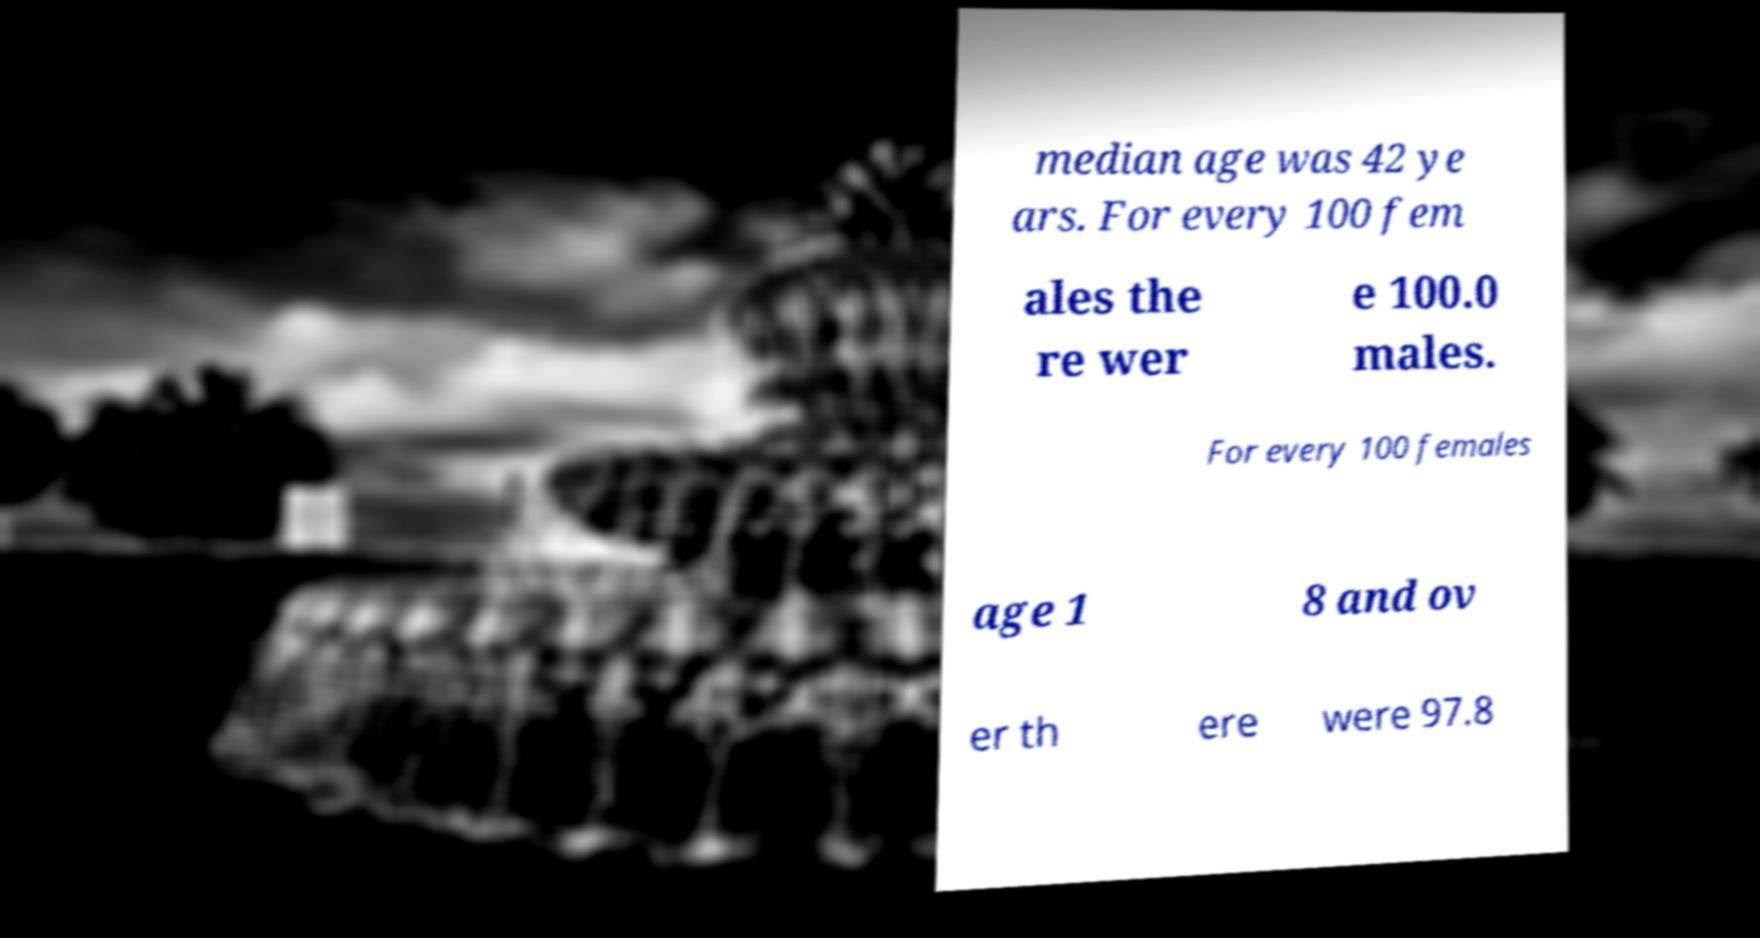Can you read and provide the text displayed in the image?This photo seems to have some interesting text. Can you extract and type it out for me? median age was 42 ye ars. For every 100 fem ales the re wer e 100.0 males. For every 100 females age 1 8 and ov er th ere were 97.8 